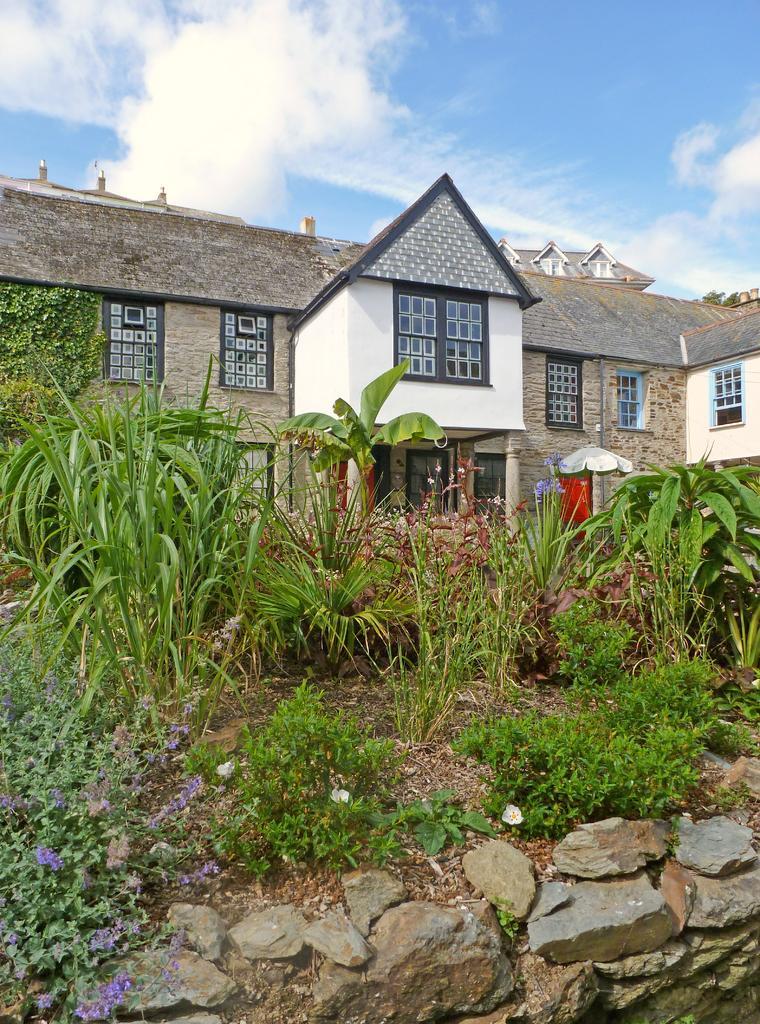Could you give a brief overview of what you see in this image? In this image I see the stones, plants and I see few flowers over here which are of purple and white in color. In the background I see the buildings and the sky and I see that the sky is of white and blue in color. 